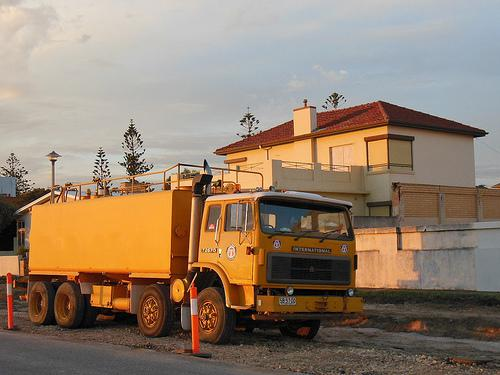Question: how many trucks are there?
Choices:
A. 6.
B. 9.
C. 1.
D. 0.
Answer with the letter. Answer: C Question: where is the truck?
Choices:
A. The driveway.
B. On the grass.
C. On the dirt.
D. The street.
Answer with the letter. Answer: D Question: when was the photo taken?
Choices:
A. At night.
B. Day time.
C. At dawn.
D. At dusk.
Answer with the letter. Answer: B Question: what is white?
Choices:
A. The street.
B. The building.
C. The car.
D. The truck.
Answer with the letter. Answer: B Question: why is it so bright?
Choices:
A. Lamp light.
B. Fire light.
C. Sun light.
D. Computer screen light.
Answer with the letter. Answer: C 